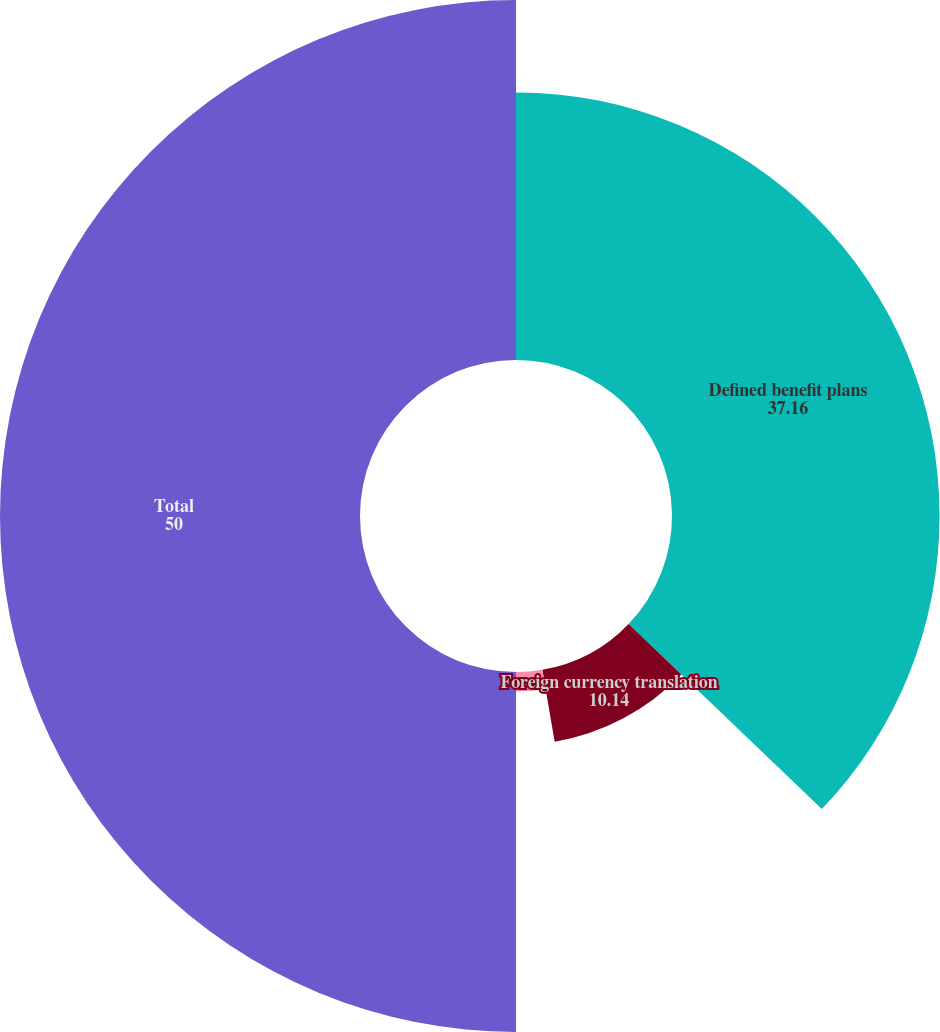Convert chart to OTSL. <chart><loc_0><loc_0><loc_500><loc_500><pie_chart><fcel>Defined benefit plans<fcel>Foreign currency translation<fcel>Derivatives<fcel>Total<nl><fcel>37.16%<fcel>10.14%<fcel>2.7%<fcel>50.0%<nl></chart> 